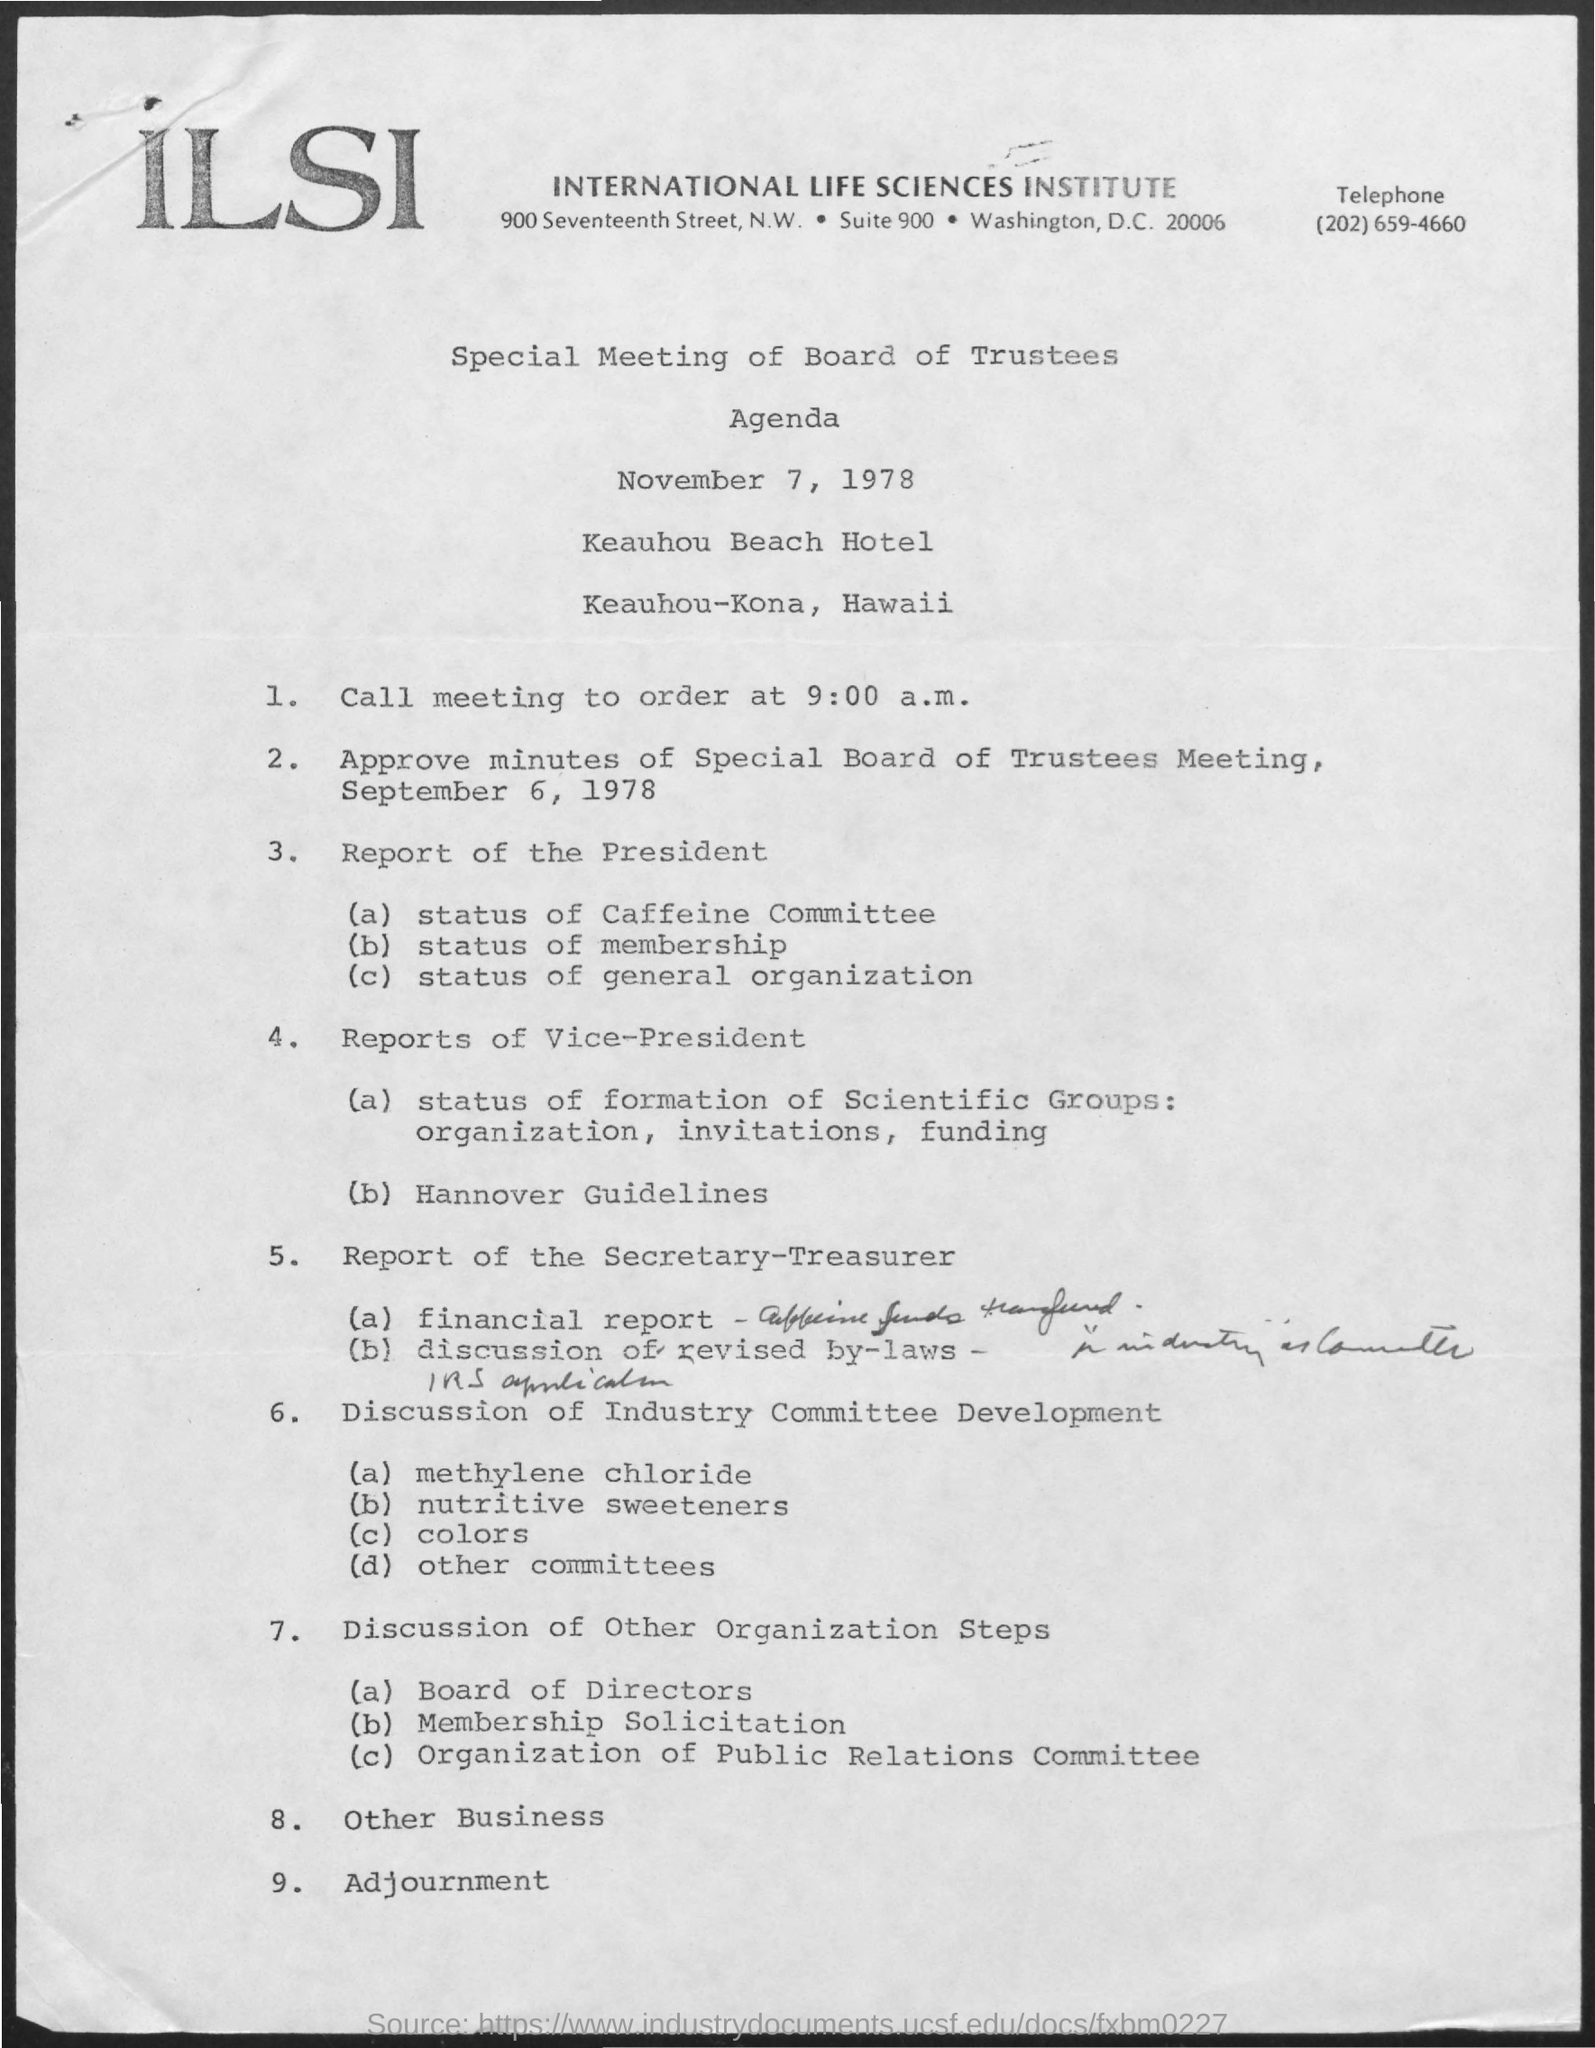What is last agenda?
Keep it short and to the point. Adjournment. How many agendas are there?
Your response must be concise. 9. What is the date of Special Meeting of Board Trustees?
Make the answer very short. November 7, 1978. 